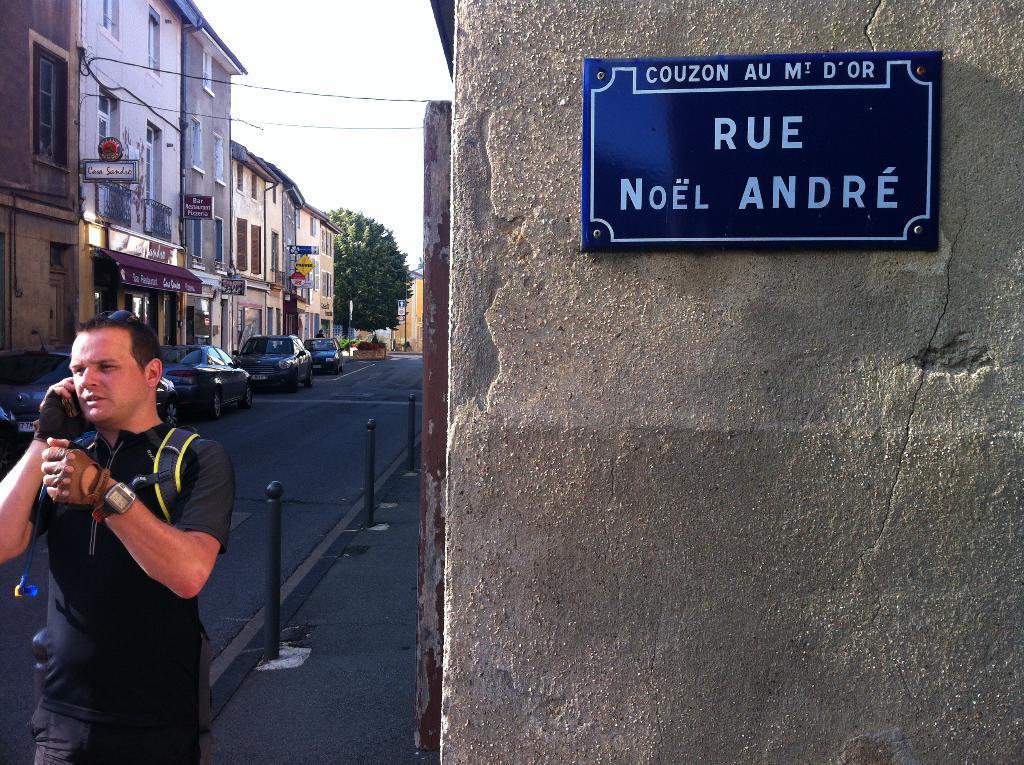Please provide a concise description of this image. In this image I can see a man and I can see he is wearing a watch and gloves. I can also see he is carrying a bag. Here I can see a blue colour board on wall and on this board I can see something is written. In the background I can see number of buildings, a tree, vehicles, few boards, wires, few poles and on these words I can see something is written. 